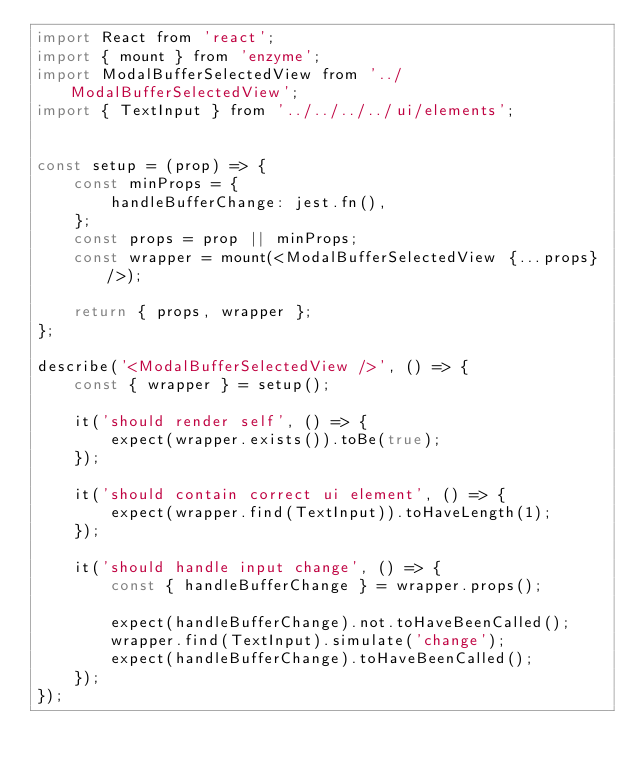Convert code to text. <code><loc_0><loc_0><loc_500><loc_500><_JavaScript_>import React from 'react';
import { mount } from 'enzyme';
import ModalBufferSelectedView from '../ModalBufferSelectedView';
import { TextInput } from '../../../../ui/elements';


const setup = (prop) => {
    const minProps = {
        handleBufferChange: jest.fn(),
    };
    const props = prop || minProps;
    const wrapper = mount(<ModalBufferSelectedView {...props} />);

    return { props, wrapper };
};

describe('<ModalBufferSelectedView />', () => {
    const { wrapper } = setup();

    it('should render self', () => {
        expect(wrapper.exists()).toBe(true);
    });

    it('should contain correct ui element', () => {
        expect(wrapper.find(TextInput)).toHaveLength(1);
    });

    it('should handle input change', () => {
        const { handleBufferChange } = wrapper.props();

        expect(handleBufferChange).not.toHaveBeenCalled();
        wrapper.find(TextInput).simulate('change');
        expect(handleBufferChange).toHaveBeenCalled();
    });
});
</code> 